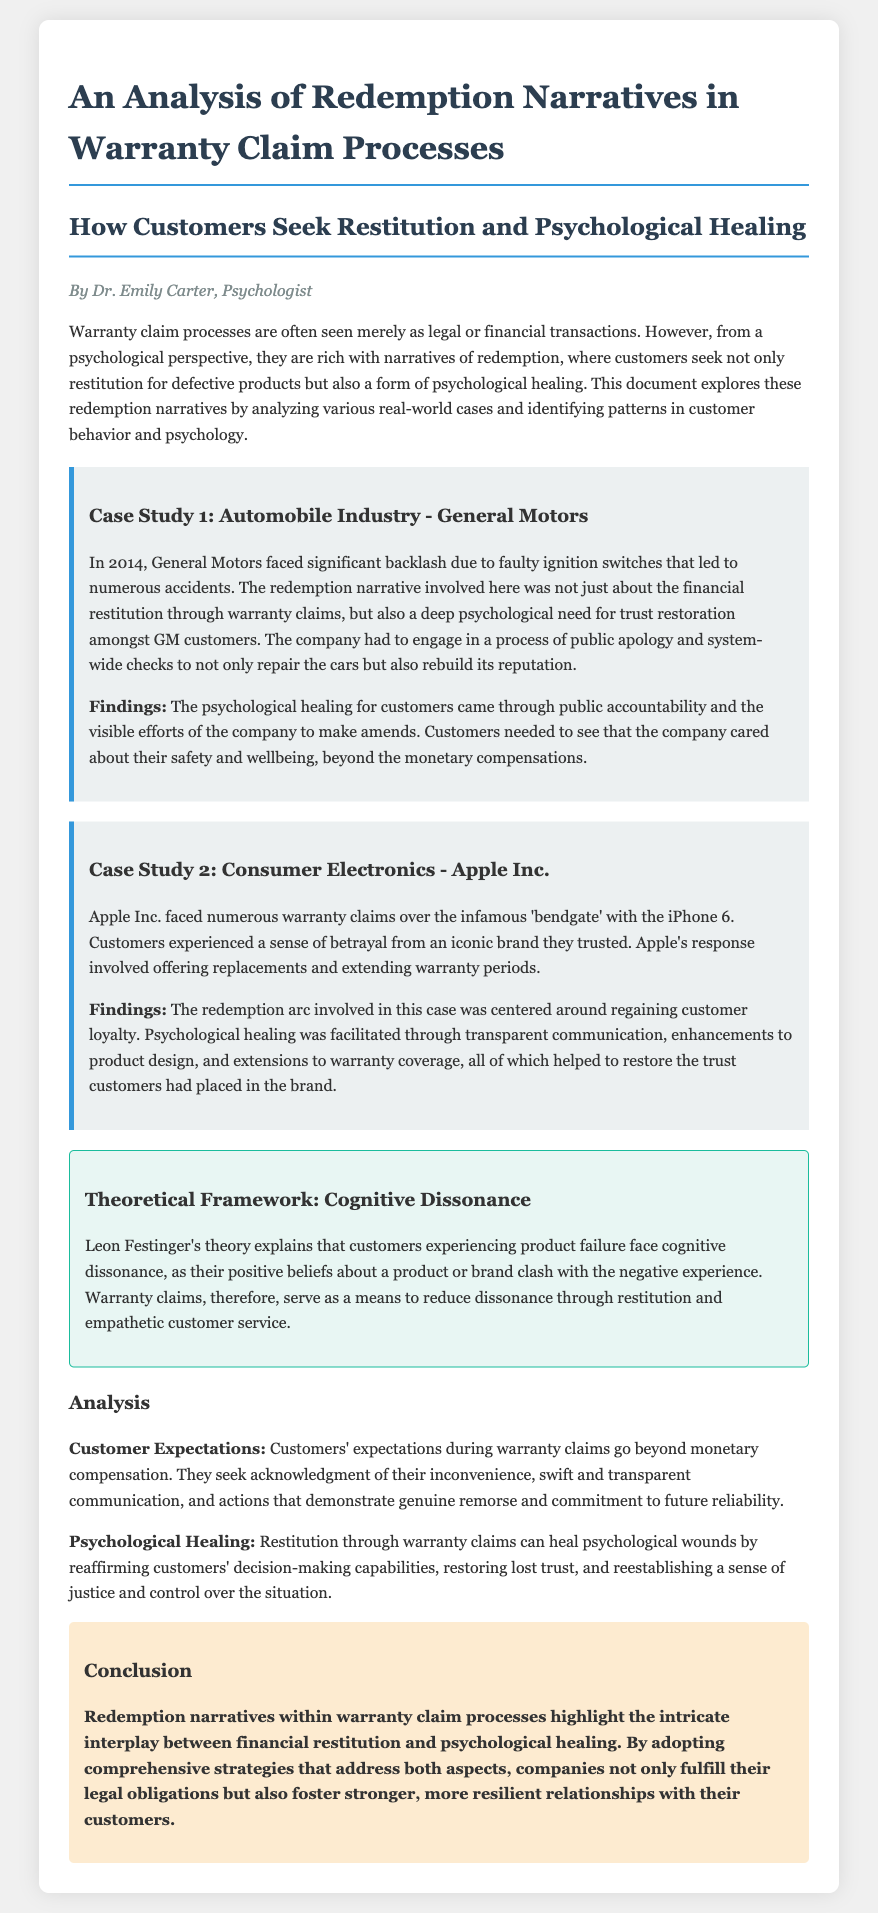What is the author's name? The author's name is provided in the document as Dr. Emily Carter.
Answer: Dr. Emily Carter What case study involves General Motors? The document specifically mentions General Motors in the context of a warranty claim related to faulty ignition switches.
Answer: General Motors What psychological theory is discussed in the document? Theoretical framework introduced in the document is Leon Festinger's theory of cognitive dissonance.
Answer: Cognitive dissonance How many case studies are analyzed in the document? The document analyzes two case studies, one for General Motors and the other for Apple Inc.
Answer: Two What key aspect do customers seek in warranty claims? The document states that customers seek acknowledgment of their inconvenience during warranty claims.
Answer: Acknowledgment What year did General Motors face backlash for ignition switches? The document lists the year as 2014 when General Motors faced significant backlash.
Answer: 2014 What primary concept is linked to psychological healing in warranty claims? The document indicates that psychological healing is facilitated through restoration of trust among customers.
Answer: Restoration of trust What is the background color of the case study section? The document describes the case study section with a background color of #ecf0f1.
Answer: #ecf0f1 